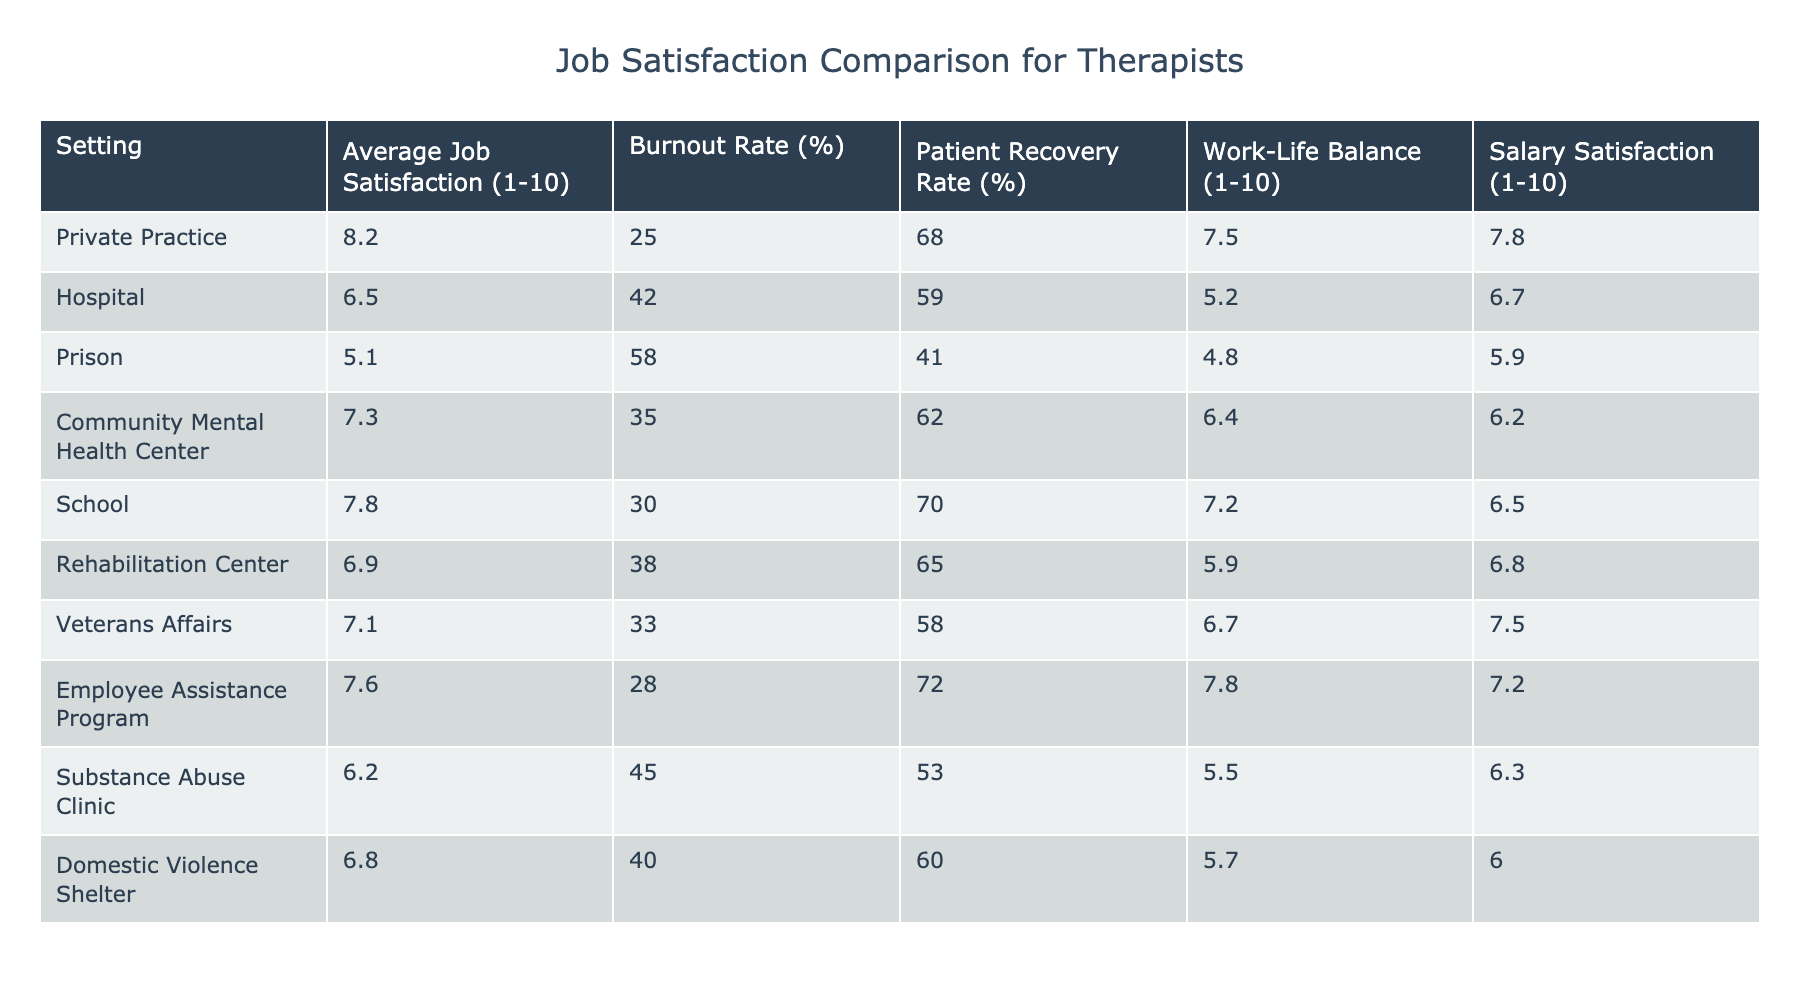What is the average job satisfaction level for therapists working in private practice? The table shows that the average job satisfaction level in private practice is listed under the "Average Job Satisfaction (1-10)" column, which is 8.2.
Answer: 8.2 Which setting has the highest burnout rate? By examining the "Burnout Rate (%)" column, the highest value is 58%, which corresponds to the Prison setting.
Answer: Prison What is the average work-life balance rating for therapists in community mental health centers and rehabilitation centers? The work-life balance ratings are 6.4 for community mental health centers and 5.9 for rehabilitation centers. To find the average: (6.4 + 5.9) / 2 = 6.15.
Answer: 6.15 Is the patient recovery rate in schools higher than in prisons? The table shows that the patient recovery rate in schools is 70% and in prisons it is 41%. Since 70% is greater than 41%, the answer is yes.
Answer: Yes What is the difference in average job satisfaction between therapists working in hospitals and those in employee assistance programs? The average job satisfaction for hospitals is 6.5 and for employee assistance programs it is 7.6. To find the difference: 7.6 - 6.5 = 1.1.
Answer: 1.1 What percentage of therapists in the prison setting are likely to experience burnout? The table indicates that the burnout rate for therapists in the prison setting is 58%.
Answer: 58% Which setting shows the highest patient recovery rate and what is that rate? The highest patient recovery rate listed in the table is 72%, which corresponds to the Employee Assistance Program setting.
Answer: 72% Are therapists working in substance abuse clinics more satisfied with their salary than those in community mental health centers? The salary satisfaction for substance abuse clinics is 6.3, while for community mental health centers it is 6.2. Since 6.3 is greater than 6.2, the answer is yes.
Answer: Yes How does the work-life balance of therapists in private practice compare to those in hospitals? The work-life balance rating for private practice is 7.5, while for hospitals it is 5.2. If we calculate the difference: 7.5 - 5.2 = 2.3, it indicates private practice has a better work-life balance.
Answer: 2.3 